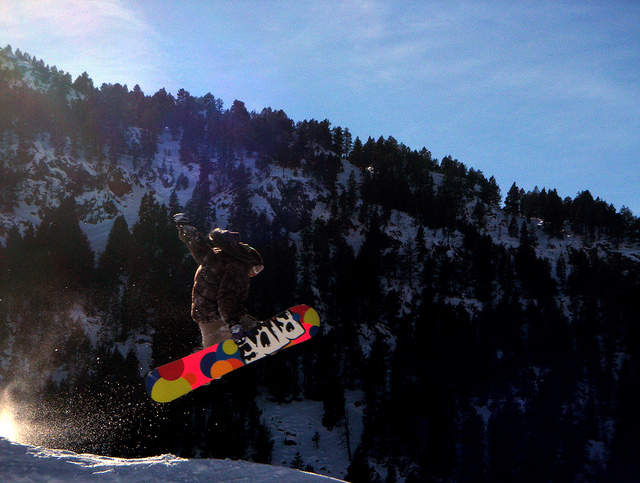Read all the text in this image. RIOE 